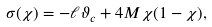Convert formula to latex. <formula><loc_0><loc_0><loc_500><loc_500>\sigma ( \chi ) = - \ell \vartheta _ { c } + 4 M \chi ( 1 - \chi ) ,</formula> 